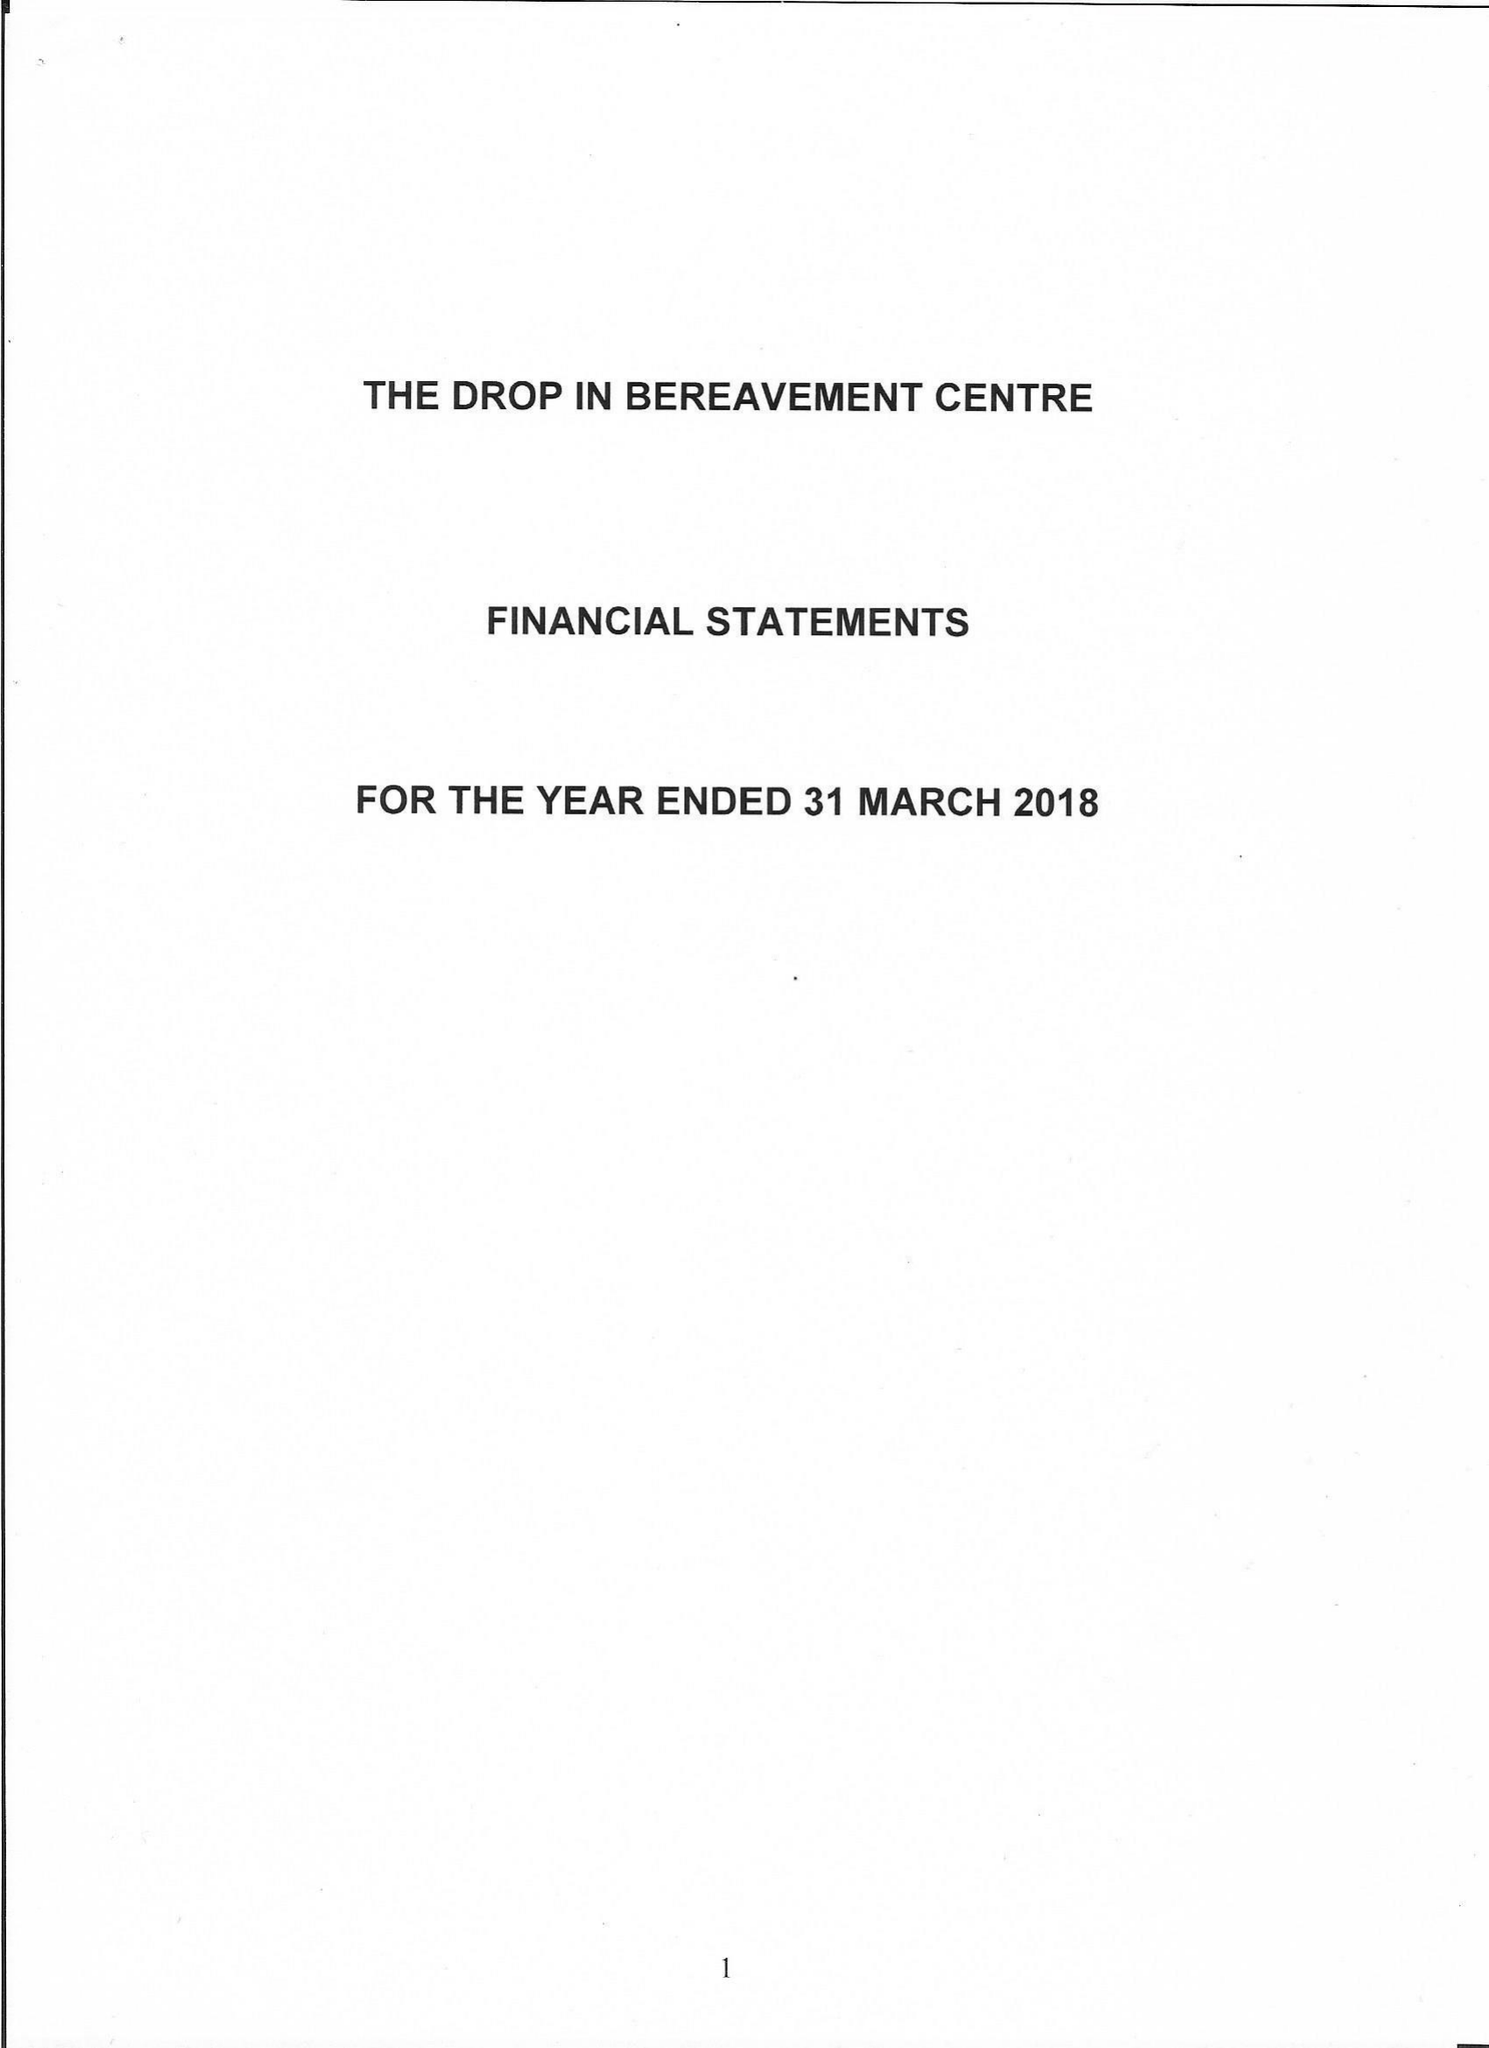What is the value for the income_annually_in_british_pounds?
Answer the question using a single word or phrase. 18116.00 